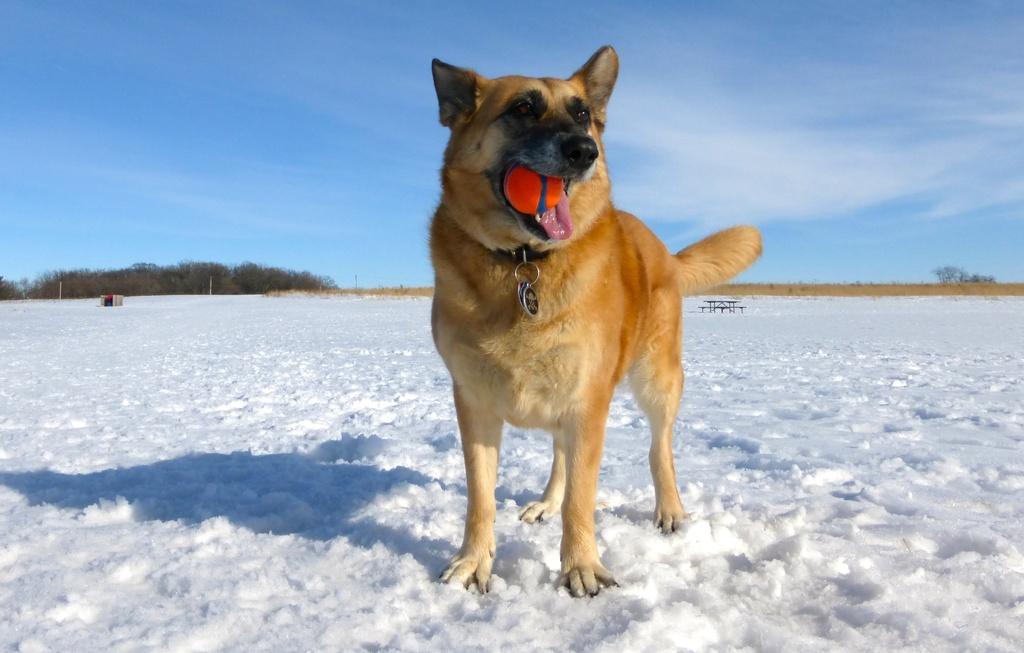Please provide a concise description of this image. In this image there is a dog holding a ball with its mouth. Dog is standing on the snow. There is a bench on the snow. Left side there are few trees. Right side there are few trees on the land. Top of image there is sky. 